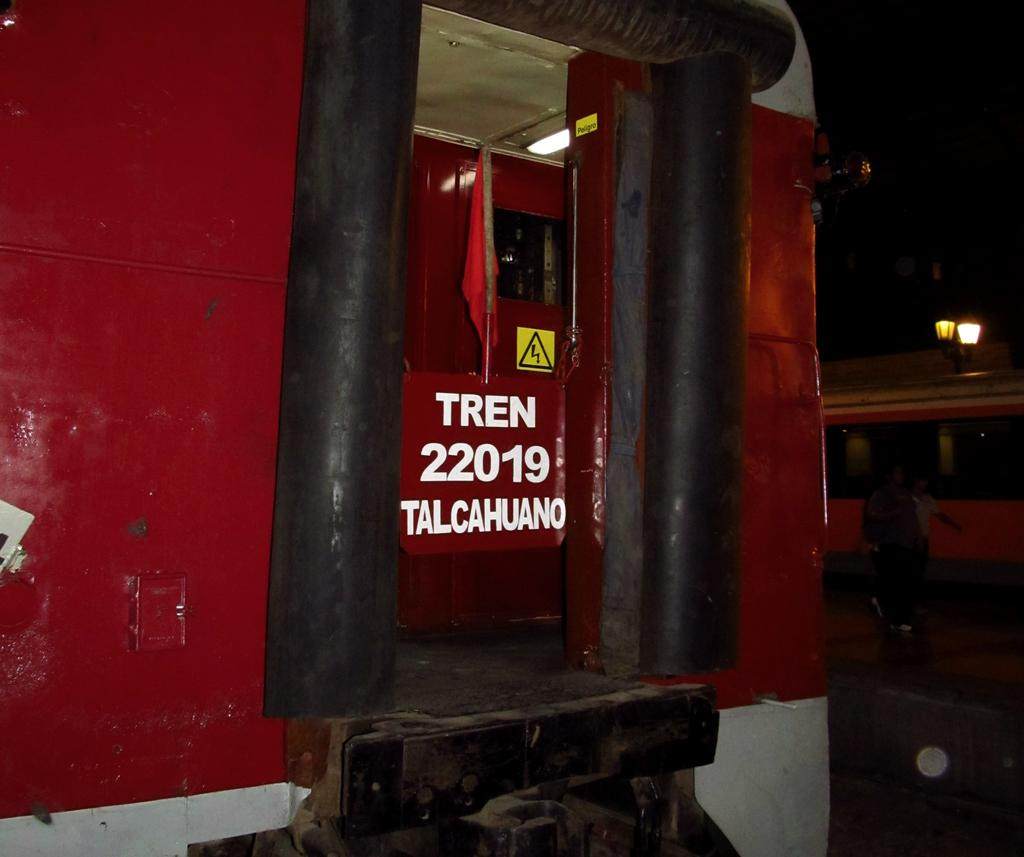What type of vehicles are present in the image? There are trains in the image. What else can be seen in the image besides the trains? There are lights and people visible in the image. How would you describe the lighting in the image? The background of the image is dark. What type of magic is being performed by the mice in the image? There are no mice present in the image, so no magic can be observed. What is the base of the structure in the image? There is no structure with a base in the image; it features trains, lights, and people. 